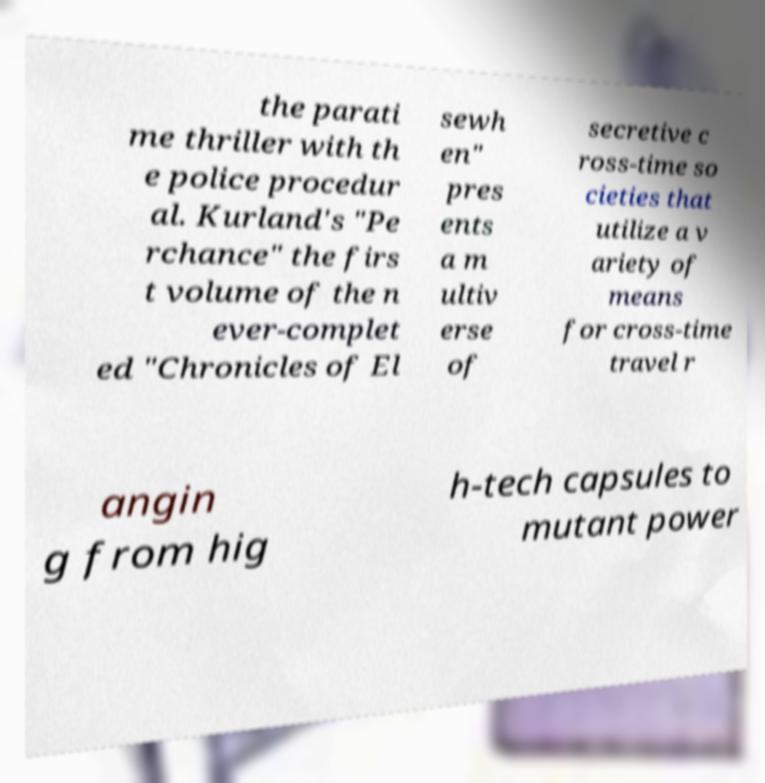Can you read and provide the text displayed in the image?This photo seems to have some interesting text. Can you extract and type it out for me? the parati me thriller with th e police procedur al. Kurland's "Pe rchance" the firs t volume of the n ever-complet ed "Chronicles of El sewh en" pres ents a m ultiv erse of secretive c ross-time so cieties that utilize a v ariety of means for cross-time travel r angin g from hig h-tech capsules to mutant power 